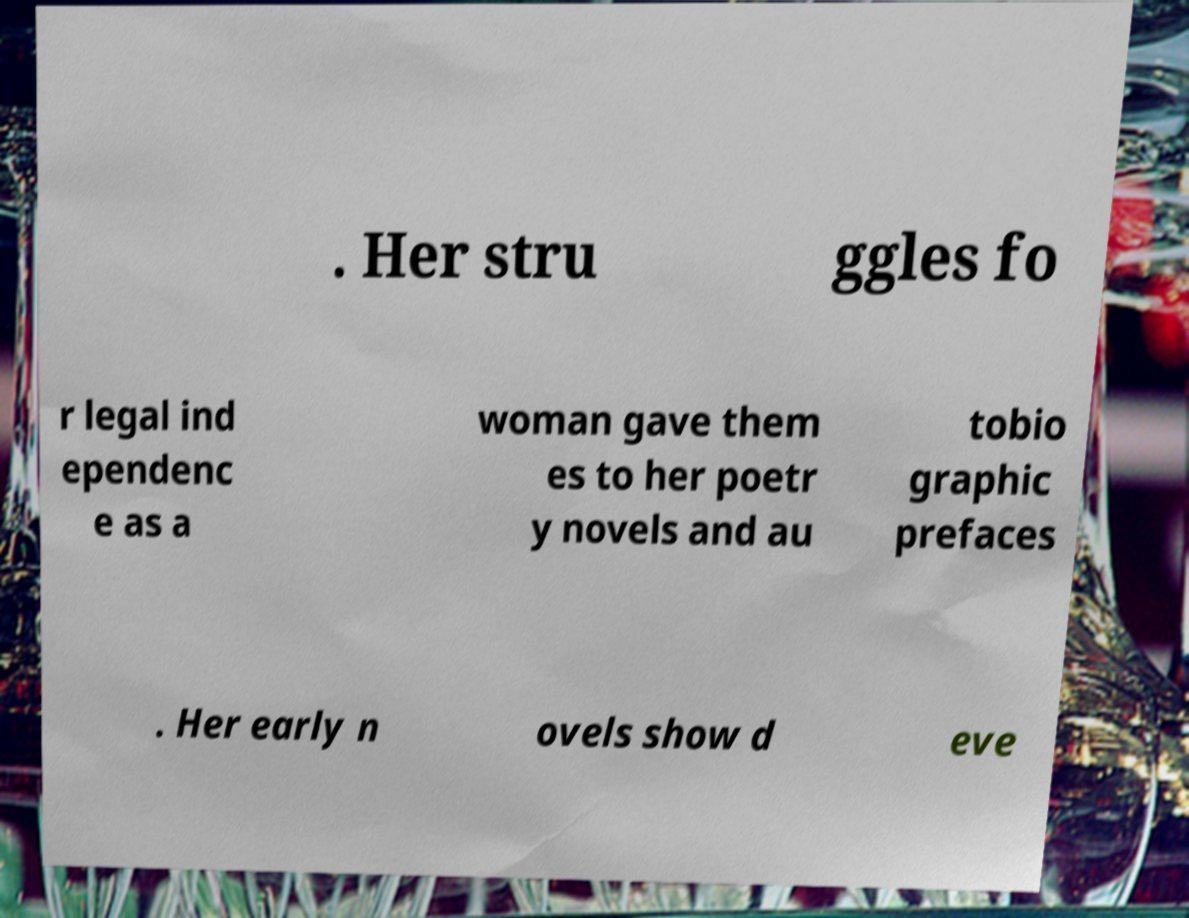There's text embedded in this image that I need extracted. Can you transcribe it verbatim? . Her stru ggles fo r legal ind ependenc e as a woman gave them es to her poetr y novels and au tobio graphic prefaces . Her early n ovels show d eve 